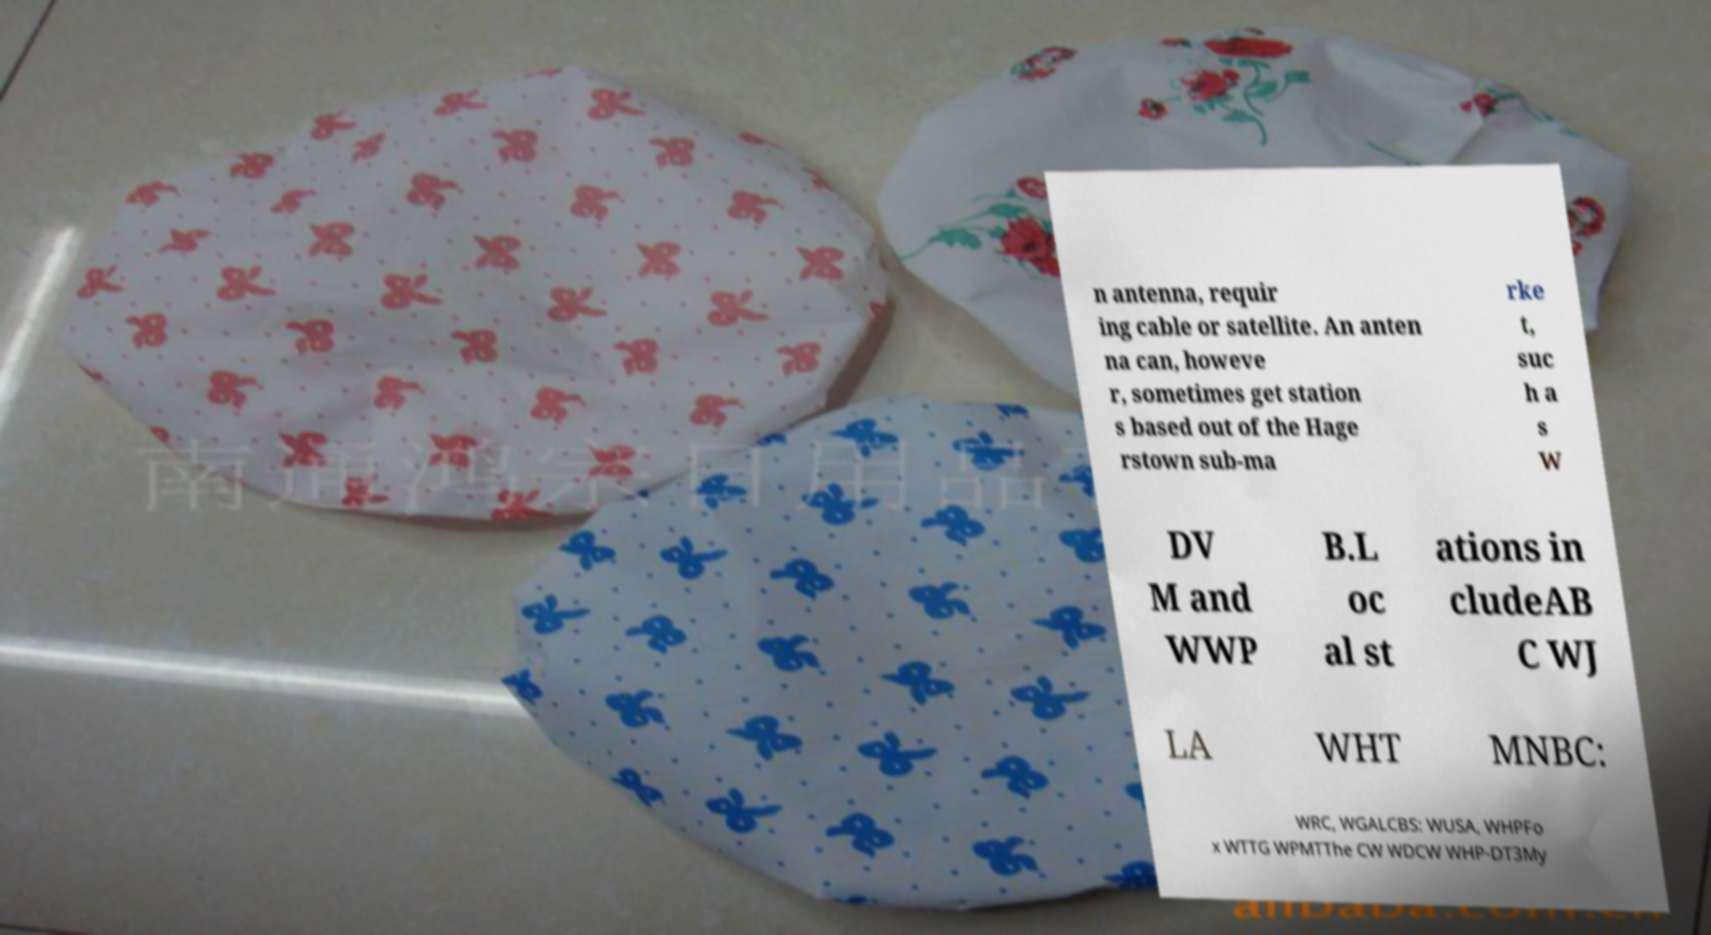Please read and relay the text visible in this image. What does it say? n antenna, requir ing cable or satellite. An anten na can, howeve r, sometimes get station s based out of the Hage rstown sub-ma rke t, suc h a s W DV M and WWP B.L oc al st ations in cludeAB C WJ LA WHT MNBC: WRC, WGALCBS: WUSA, WHPFo x WTTG WPMTThe CW WDCW WHP-DT3My 